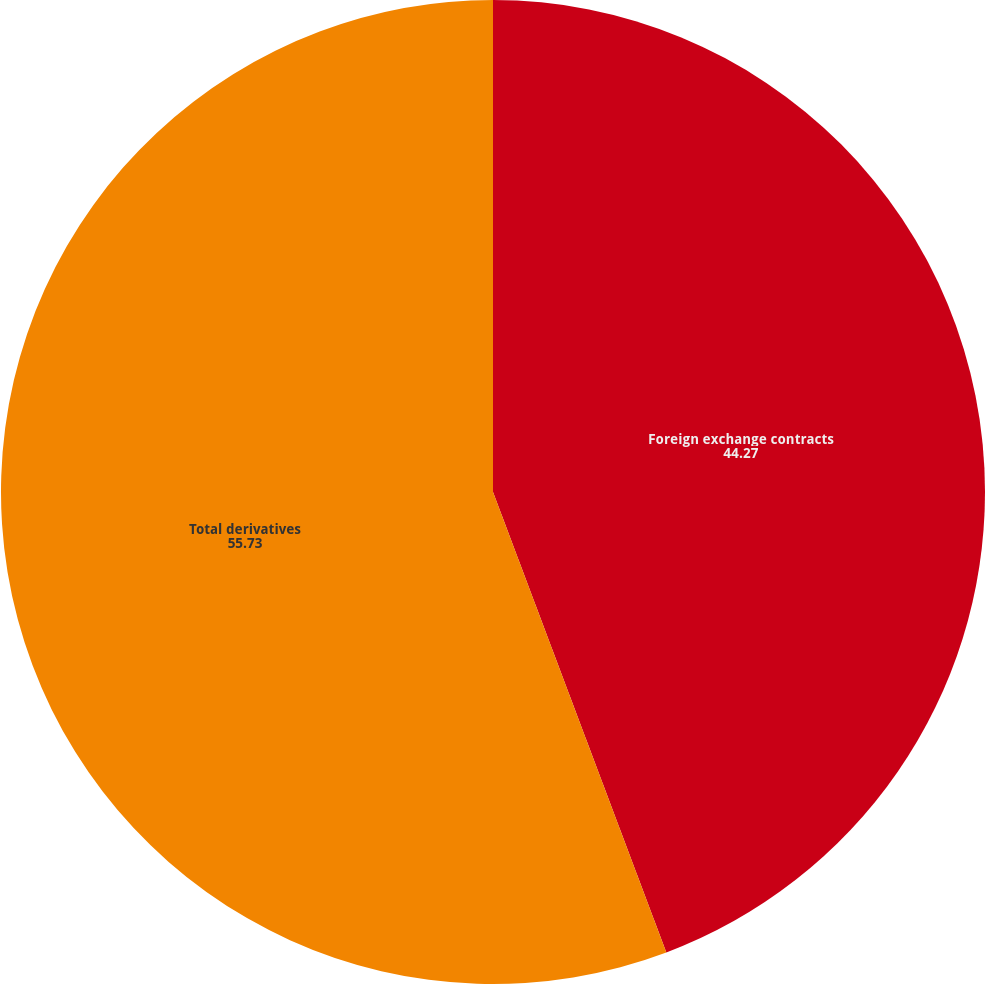Convert chart. <chart><loc_0><loc_0><loc_500><loc_500><pie_chart><fcel>Foreign exchange contracts<fcel>Total derivatives<nl><fcel>44.27%<fcel>55.73%<nl></chart> 